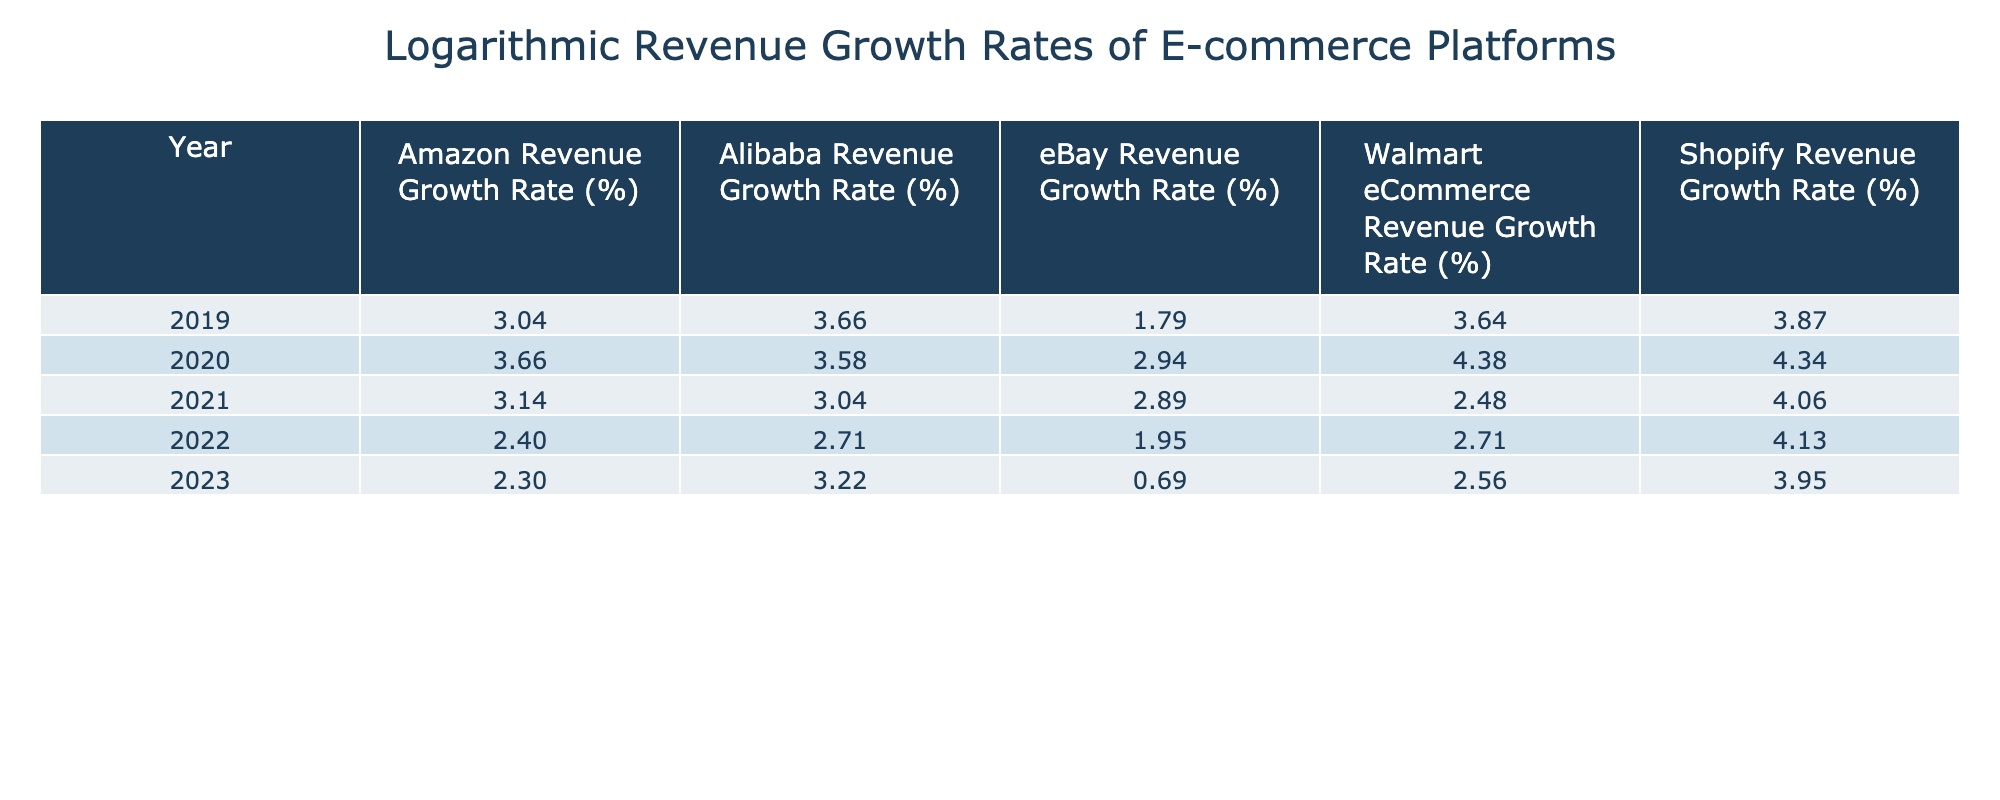What was the revenue growth rate of Amazon in 2020? In the table, the revenue growth rate for Amazon in 2020 is specifically listed. Referring to that row, Amazon's growth rate for that year is 38%.
Answer: 38% Which e-commerce platform had the highest revenue growth rate in 2021? By comparing the revenue growth rates for all platforms in 2021 across the table, Shopify has the highest growth rate of 57%.
Answer: Shopify What is the average revenue growth rate of eBay over the five years? To calculate the average, we sum the growth rates for eBay from 2019 to 2023: (5 + 18 + 17 + 6 + 1) = 47. Dividing by the number of years (5) yields an average of 47/5 = 9.4%.
Answer: 9.4% Did Walmart's eCommerce revenue growth rate increase every year from 2019 to 2023? By examining the annual growth rates for Walmart in the table, we find that the growth rate was 37% in 2019 but decreased in the following years. Therefore, it did not increase every year.
Answer: No What is the difference in revenue growth rate between Shopify and Alibaba in 2022? The table shows that Shopify had a growth rate of 61% and Alibaba had a rate of 14% in 2022. The difference is calculated as 61 - 14 = 47%.
Answer: 47% Which platform experienced a decrease in growth rate from 2021 to 2022? Looking at the growth rates from 2021 to 2022 for each platform, Amazon's growth rate dropped from 22% to 10%, eBay's from 17% to 6%, and Walmart's from 11% to 14%. Hence, those three platforms experienced a decrease.
Answer: Amazon, eBay Which platform had a balanced growth trend in the last five years, i.e., consistent growth without drastic rises or drops? By closely examining the growth rates of each platform from year to year, eBay shows minimal fluctuations compared to the others, suggesting a more stable growth trend overall despite any rises or falls.
Answer: eBay What was the growth rate for Alibaba in 2019 and how does it compare to 2023? The growth rate for Alibaba in 2019 was 38%, and in 2023, it was 24%. This indicates a decrease of 14%.
Answer: Decrease of 14% Was 2020 the year with the highest growth rate for Walmart's eCommerce? Analyzing the table, Walmart's eCommerce growth rate in 2020 was 79%, which is the highest when compared to other years listed.
Answer: Yes 